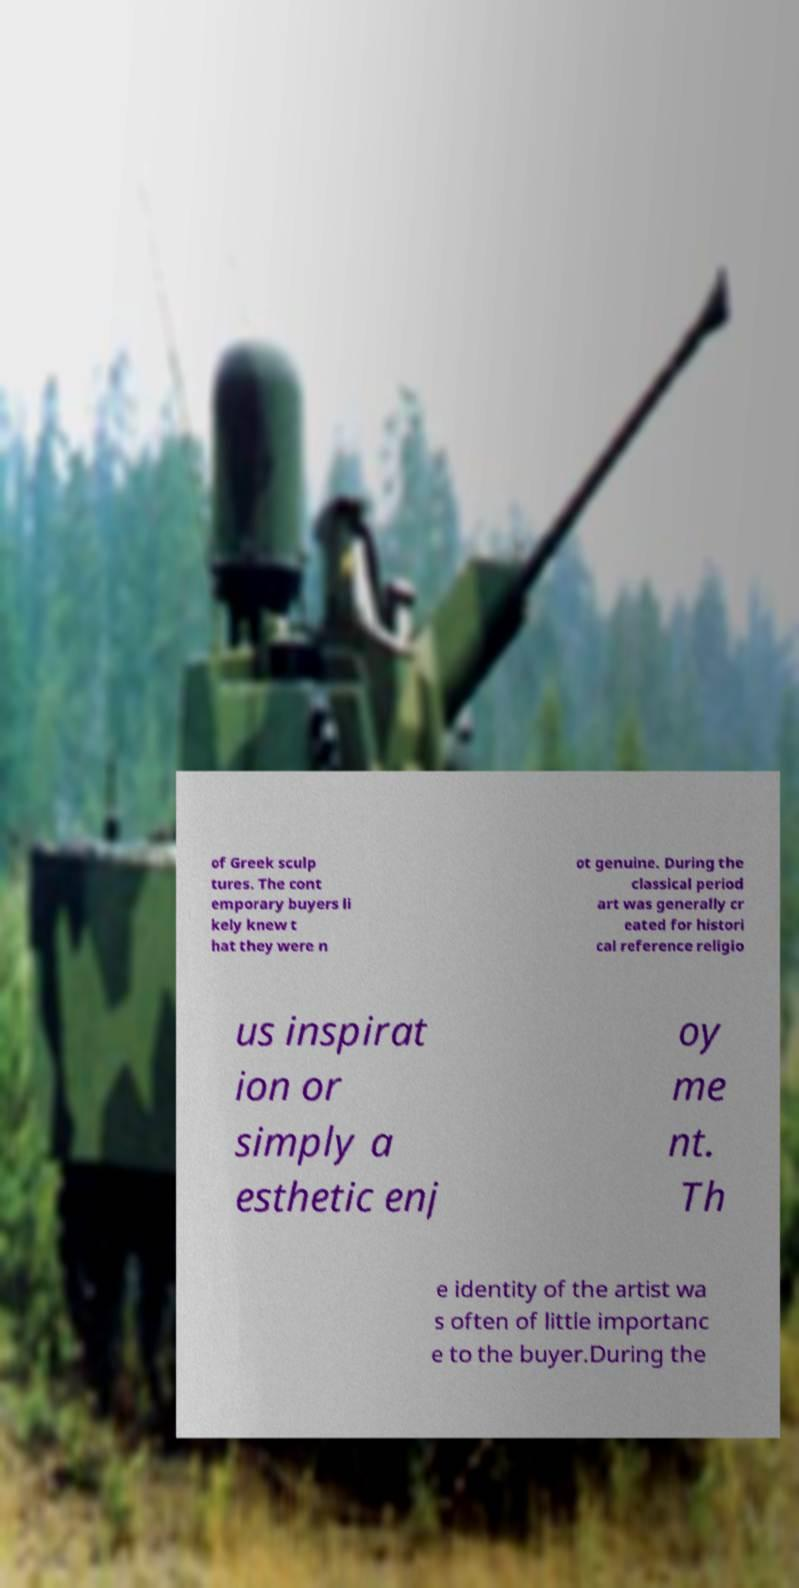For documentation purposes, I need the text within this image transcribed. Could you provide that? of Greek sculp tures. The cont emporary buyers li kely knew t hat they were n ot genuine. During the classical period art was generally cr eated for histori cal reference religio us inspirat ion or simply a esthetic enj oy me nt. Th e identity of the artist wa s often of little importanc e to the buyer.During the 